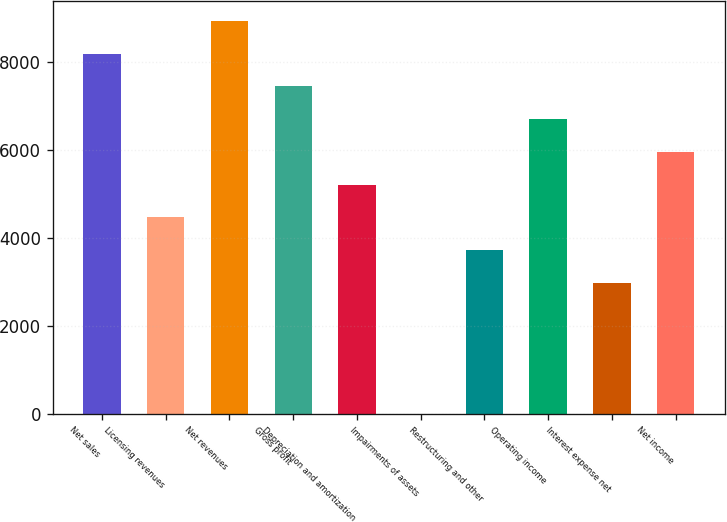<chart> <loc_0><loc_0><loc_500><loc_500><bar_chart><fcel>Net sales<fcel>Licensing revenues<fcel>Net revenues<fcel>Gross profit<fcel>Depreciation and amortization<fcel>Impairments of assets<fcel>Restructuring and other<fcel>Operating income<fcel>Interest expense net<fcel>Net income<nl><fcel>8194.9<fcel>4470.4<fcel>8939.8<fcel>7450<fcel>5215.3<fcel>1<fcel>3725.5<fcel>6705.1<fcel>2980.6<fcel>5960.2<nl></chart> 